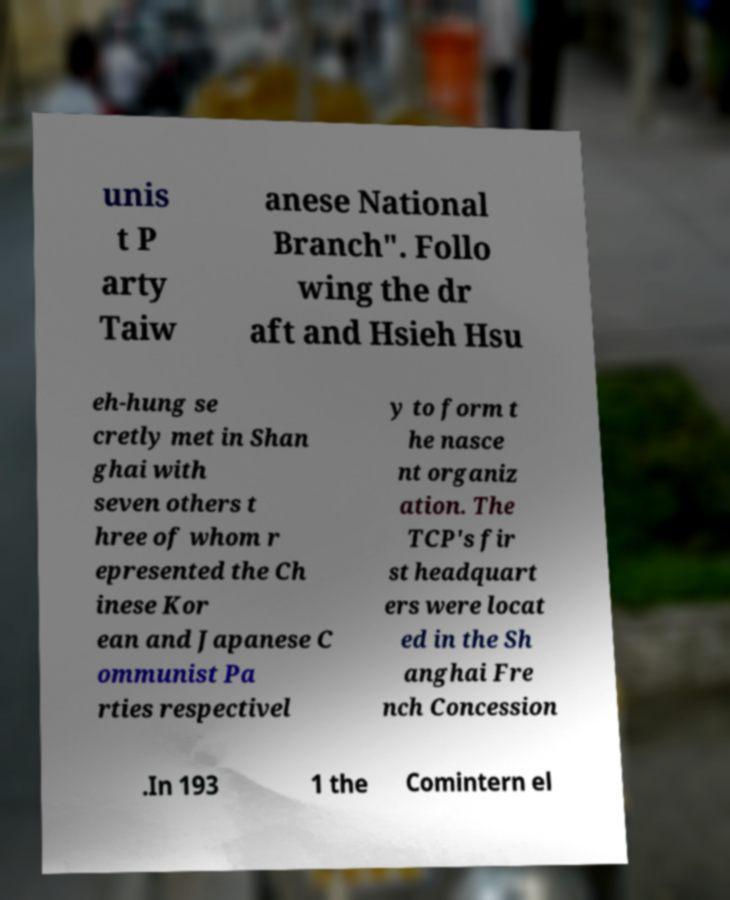Can you read and provide the text displayed in the image?This photo seems to have some interesting text. Can you extract and type it out for me? unis t P arty Taiw anese National Branch". Follo wing the dr aft and Hsieh Hsu eh-hung se cretly met in Shan ghai with seven others t hree of whom r epresented the Ch inese Kor ean and Japanese C ommunist Pa rties respectivel y to form t he nasce nt organiz ation. The TCP's fir st headquart ers were locat ed in the Sh anghai Fre nch Concession .In 193 1 the Comintern el 